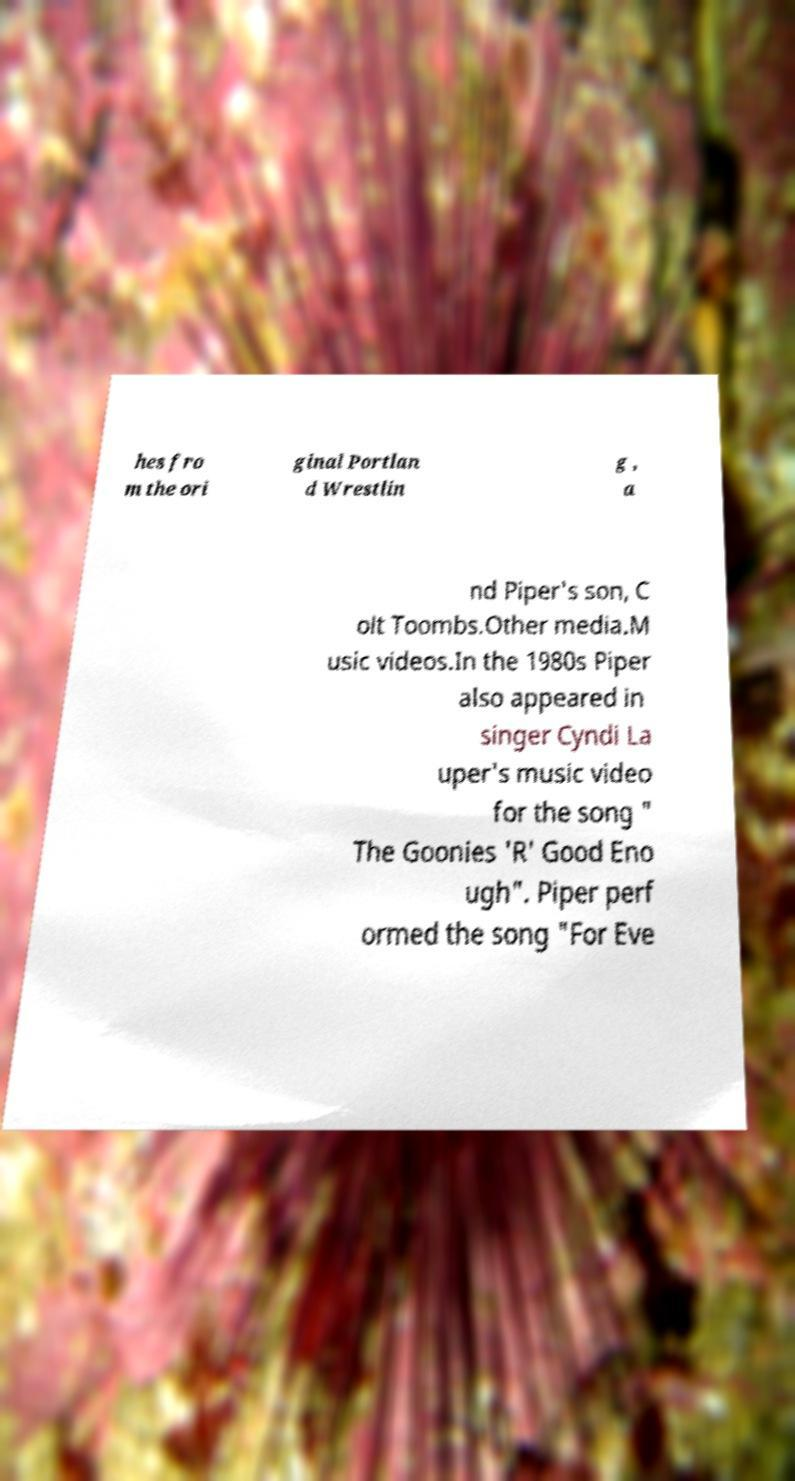Please identify and transcribe the text found in this image. hes fro m the ori ginal Portlan d Wrestlin g , a nd Piper's son, C olt Toombs.Other media.M usic videos.In the 1980s Piper also appeared in singer Cyndi La uper's music video for the song " The Goonies 'R' Good Eno ugh". Piper perf ormed the song "For Eve 